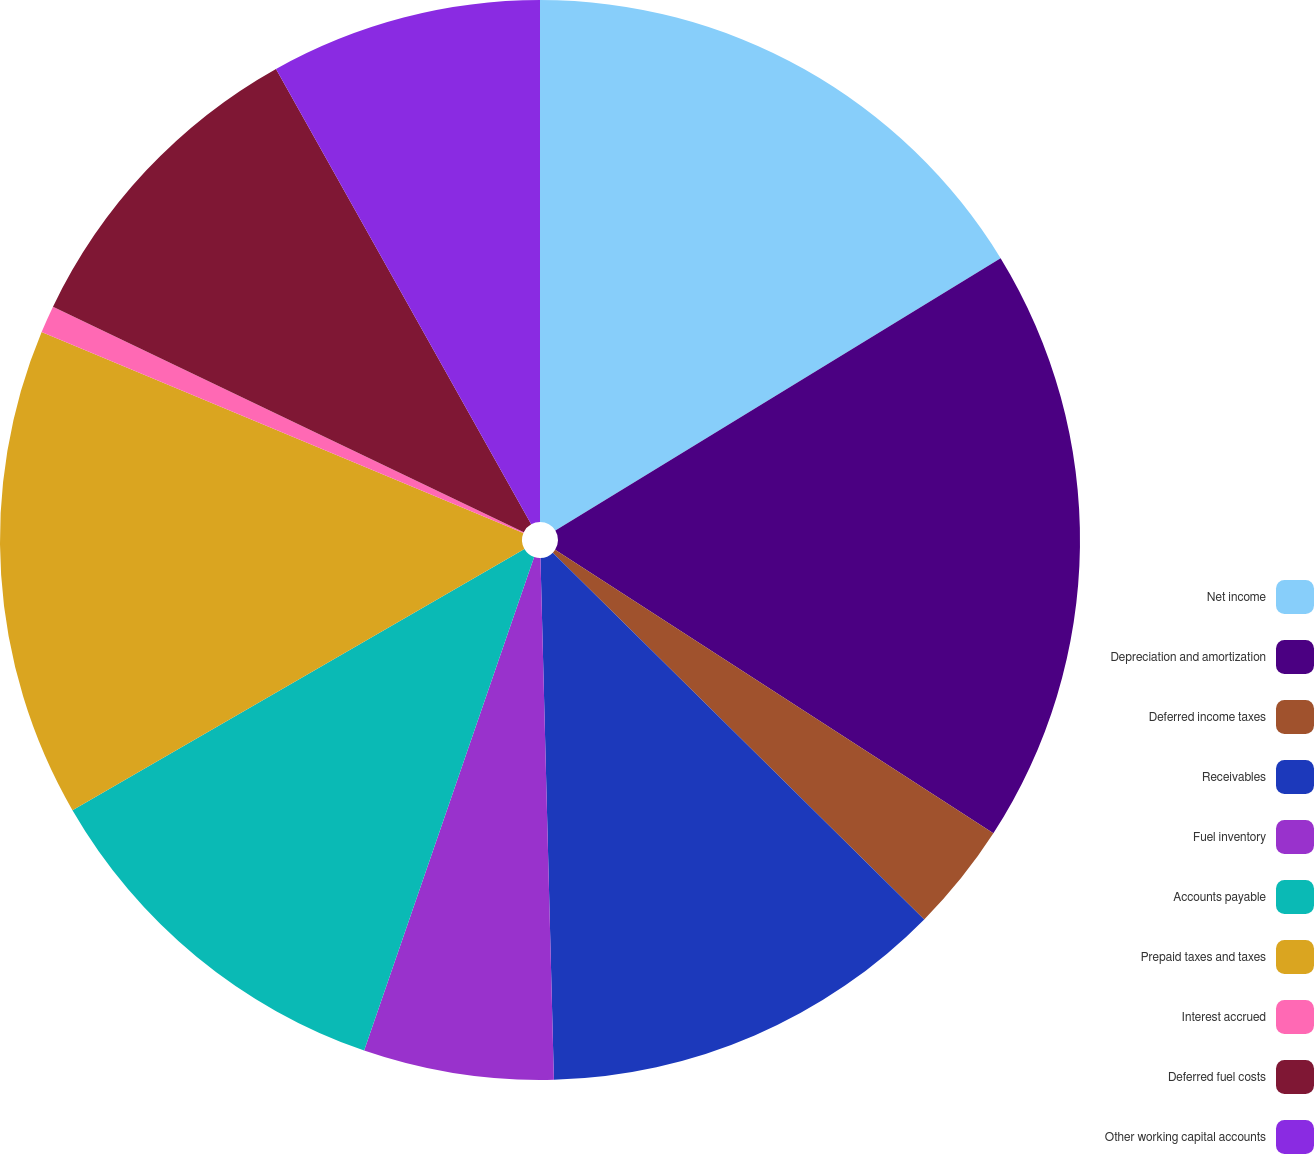Convert chart to OTSL. <chart><loc_0><loc_0><loc_500><loc_500><pie_chart><fcel>Net income<fcel>Depreciation and amortization<fcel>Deferred income taxes<fcel>Receivables<fcel>Fuel inventory<fcel>Accounts payable<fcel>Prepaid taxes and taxes<fcel>Interest accrued<fcel>Deferred fuel costs<fcel>Other working capital accounts<nl><fcel>16.26%<fcel>17.88%<fcel>3.26%<fcel>12.19%<fcel>5.69%<fcel>11.38%<fcel>14.63%<fcel>0.82%<fcel>9.76%<fcel>8.13%<nl></chart> 